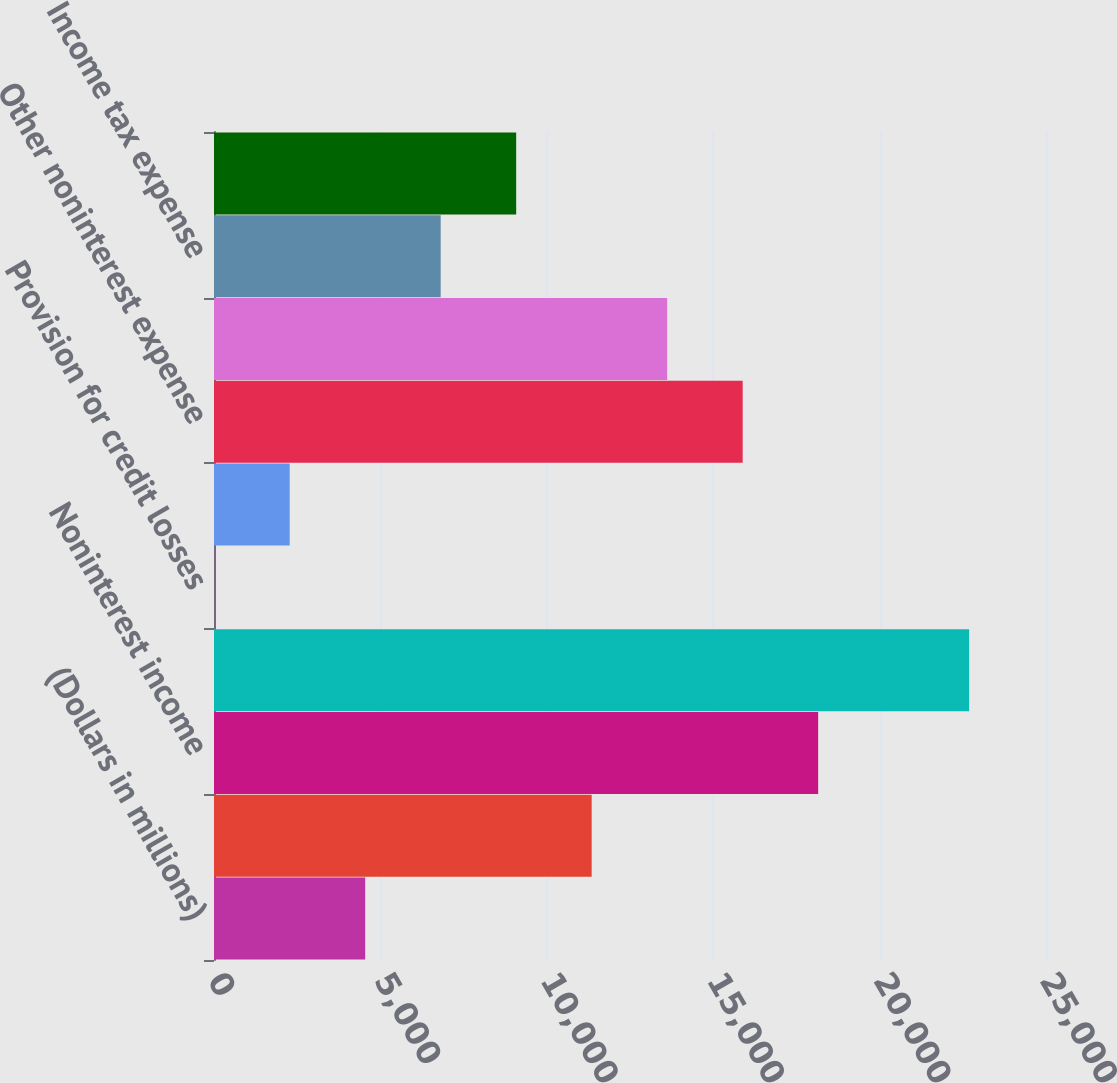Convert chart. <chart><loc_0><loc_0><loc_500><loc_500><bar_chart><fcel>(Dollars in millions)<fcel>Net interest income (FTE<fcel>Noninterest income<fcel>Total revenue (FTE basis)<fcel>Provision for credit losses<fcel>Amortization of intangibles<fcel>Other noninterest expense<fcel>Income before income taxes<fcel>Income tax expense<fcel>Net income<nl><fcel>4543<fcel>11348.5<fcel>18154<fcel>22691<fcel>6<fcel>2274.5<fcel>15885.5<fcel>13617<fcel>6811.5<fcel>9080<nl></chart> 